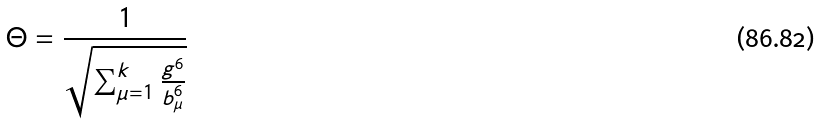<formula> <loc_0><loc_0><loc_500><loc_500>\Theta = \frac { 1 } { \sqrt { \sum _ { \mu = 1 } ^ { k } \frac { g ^ { 6 } } { b _ { \mu } ^ { 6 } } } }</formula> 